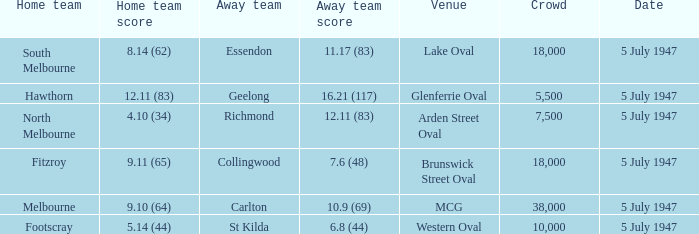Where was the game played where the away team has a score of 7.6 (48)? Brunswick Street Oval. 